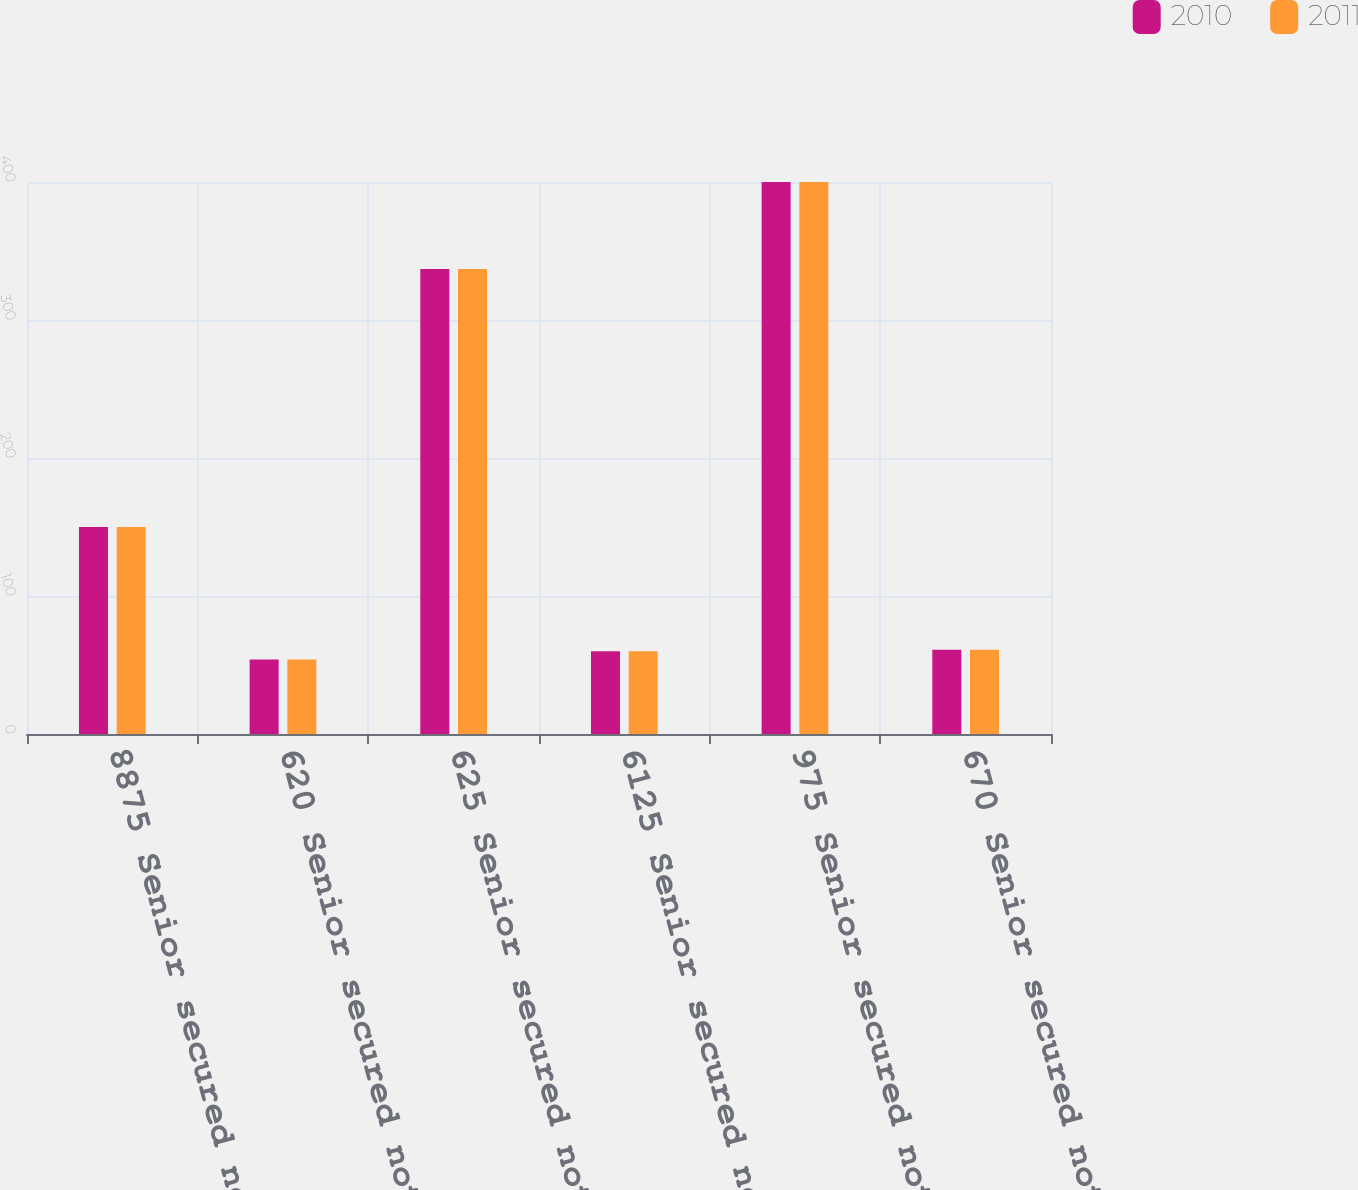<chart> <loc_0><loc_0><loc_500><loc_500><stacked_bar_chart><ecel><fcel>8875 Senior secured notes due<fcel>620 Senior secured notes due<fcel>625 Senior secured notes due<fcel>6125 Senior secured notes due<fcel>975 Senior secured notes due<fcel>670 Senior secured notes due<nl><fcel>2010<fcel>150<fcel>54<fcel>337<fcel>60<fcel>400<fcel>61<nl><fcel>2011<fcel>150<fcel>54<fcel>337<fcel>60<fcel>400<fcel>61<nl></chart> 